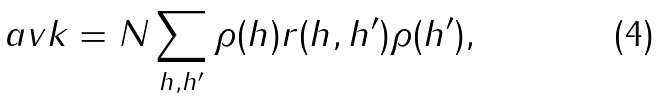Convert formula to latex. <formula><loc_0><loc_0><loc_500><loc_500>\ a v k = N \sum _ { h , h ^ { \prime } } \rho ( h ) r ( h , h ^ { \prime } ) \rho ( h ^ { \prime } ) ,</formula> 